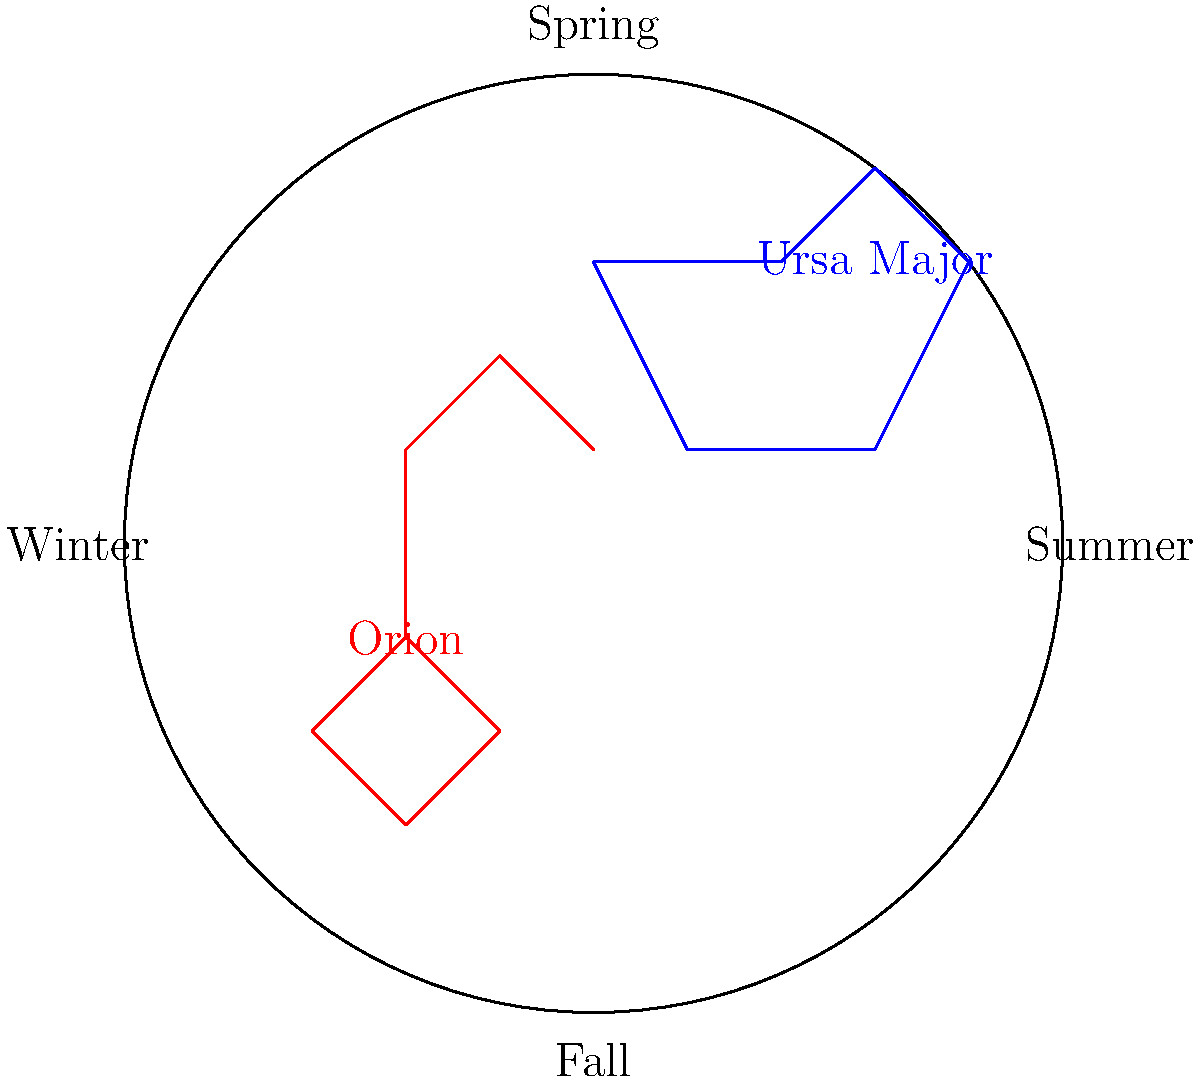As the photography club president planning a night sky photoshoot, you're using a star chart to determine the best time of year to capture specific constellations. Based on the simplified star chart provided, which season would be ideal for photographing Orion, and how does this relate to Gordon Parks' approach to capturing significant moments? To answer this question, let's break it down step-by-step:

1. Observe the star chart: The chart is divided into four seasons - Spring, Summer, Fall, and Winter.

2. Locate Orion: In the chart, Orion is depicted in red in the lower-left quadrant.

3. Determine the season: The position of Orion on the chart corresponds to the Winter section.

4. Understand visibility: Constellations are best viewed when they are highest in the night sky, which occurs during their designated season on the star chart.

5. Relate to Gordon Parks: Gordon Parks was known for his ability to capture powerful moments and tell stories through his photographs. By choosing the optimal time to photograph Orion, you're following Parks' philosophy of meticulously planning and executing shots for maximum impact.

6. Consider technical aspects: Winter nights are often clearer due to lower humidity, which aligns with Parks' attention to technical details in his photography.

7. Symbolic connection: Orion, known as "The Hunter," could symbolize Parks' hunt for truth and justice through his camera lens, adding depth to your photographic concept.
Answer: Winter, emulating Parks' strategic approach to impactful imagery. 